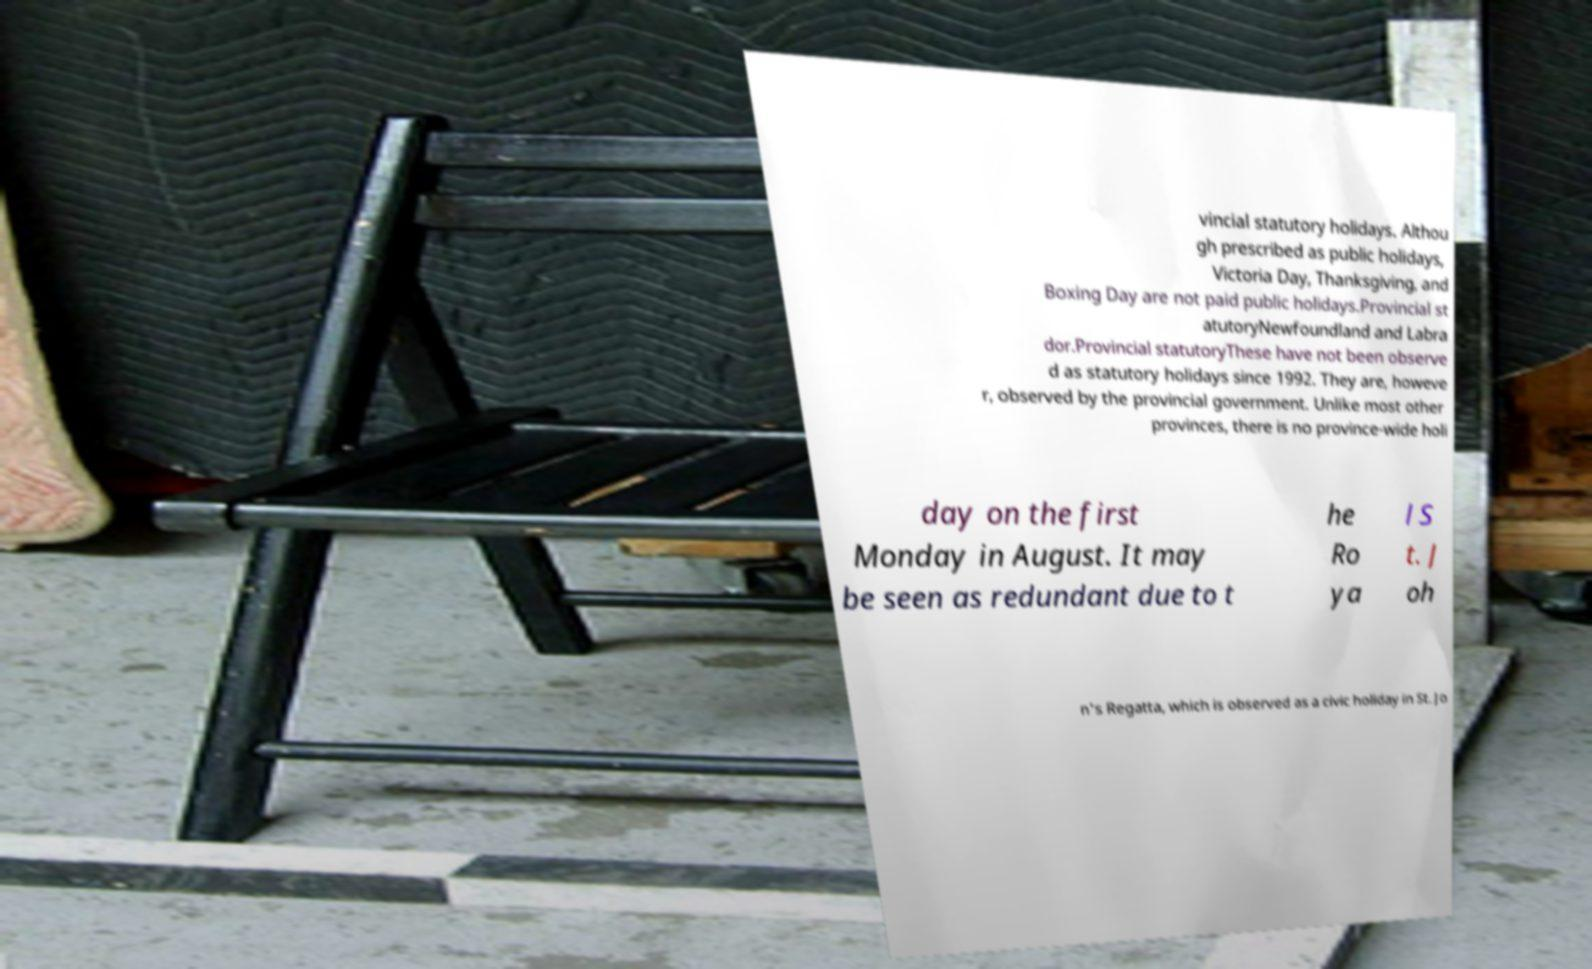Can you accurately transcribe the text from the provided image for me? vincial statutory holidays. Althou gh prescribed as public holidays, Victoria Day, Thanksgiving, and Boxing Day are not paid public holidays.Provincial st atutoryNewfoundland and Labra dor.Provincial statutoryThese have not been observe d as statutory holidays since 1992. They are, howeve r, observed by the provincial government. Unlike most other provinces, there is no province-wide holi day on the first Monday in August. It may be seen as redundant due to t he Ro ya l S t. J oh n's Regatta, which is observed as a civic holiday in St. Jo 